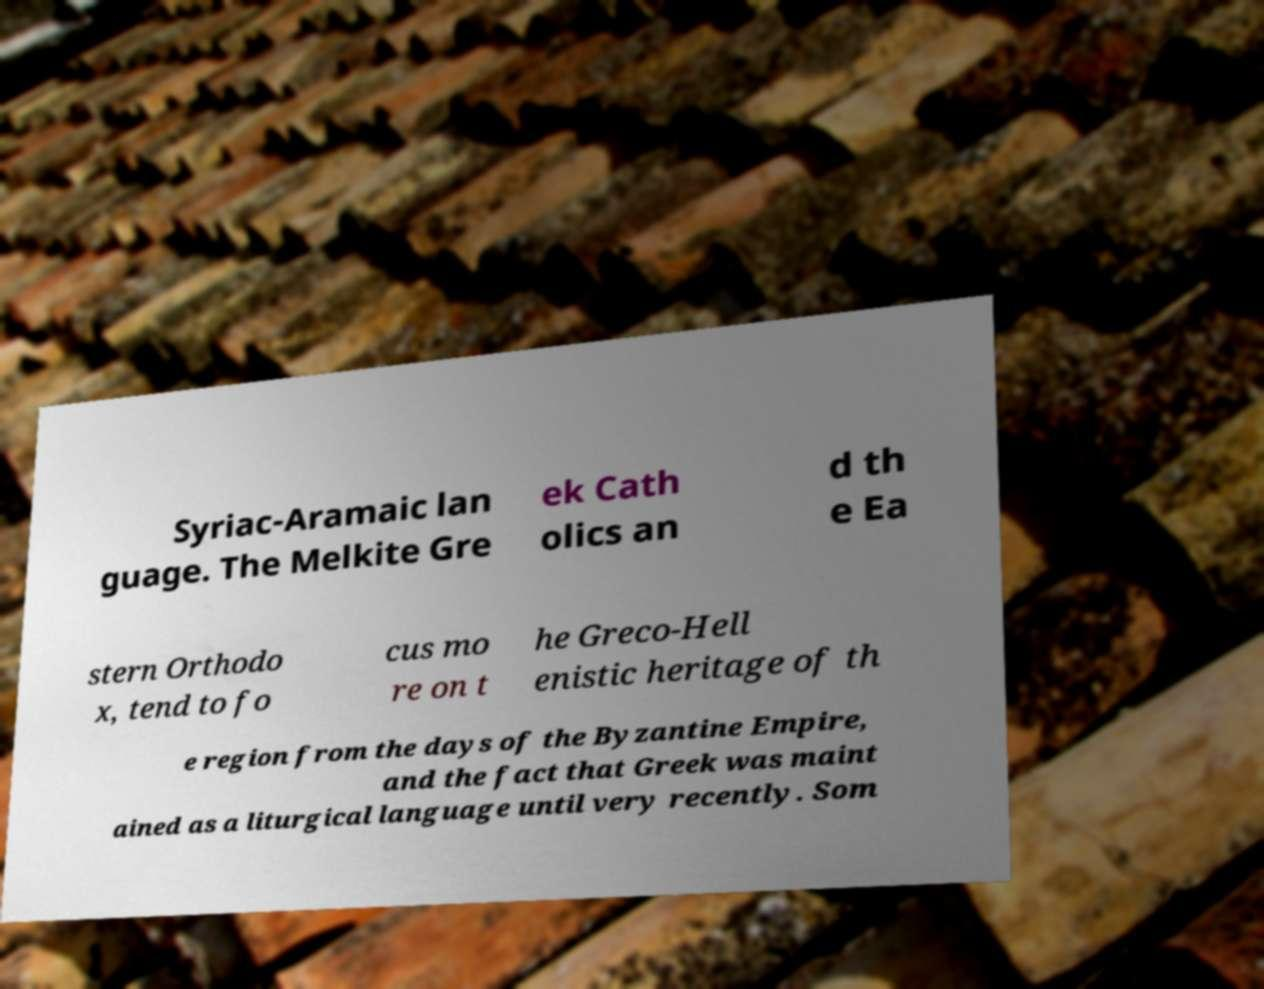Could you extract and type out the text from this image? Syriac-Aramaic lan guage. The Melkite Gre ek Cath olics an d th e Ea stern Orthodo x, tend to fo cus mo re on t he Greco-Hell enistic heritage of th e region from the days of the Byzantine Empire, and the fact that Greek was maint ained as a liturgical language until very recently. Som 